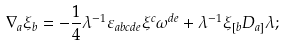Convert formula to latex. <formula><loc_0><loc_0><loc_500><loc_500>\nabla _ { a } \xi _ { b } = - \frac { 1 } { 4 } \lambda ^ { - 1 } \varepsilon _ { a b c d e } \xi ^ { c } \omega ^ { d e } + \lambda ^ { - 1 } \xi _ { [ b } D _ { a ] } \lambda ;</formula> 